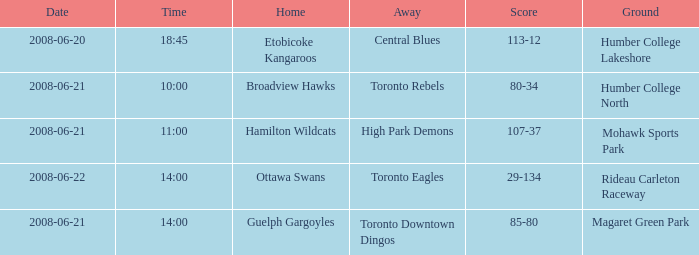What is the time for a score totaling 80-34? 10:00. 